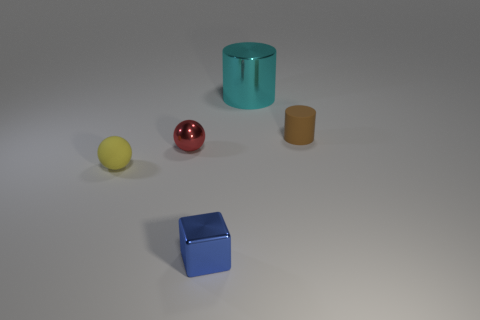Is the shape of the yellow object the same as the small red metallic thing that is on the left side of the big cyan cylinder?
Keep it short and to the point. Yes. Are there any tiny yellow objects that have the same shape as the red thing?
Provide a short and direct response. Yes. Are there the same number of tiny yellow objects that are behind the cyan cylinder and blue cubes?
Keep it short and to the point. No. How many other things are the same shape as the small yellow rubber object?
Your response must be concise. 1. There is a big shiny thing; what number of cylinders are right of it?
Keep it short and to the point. 1. What is the size of the object that is in front of the cyan shiny object and right of the blue thing?
Make the answer very short. Small. Are any big cylinders visible?
Keep it short and to the point. Yes. How many other objects are the same size as the yellow ball?
Provide a succinct answer. 3. The other object that is the same shape as the brown rubber thing is what size?
Ensure brevity in your answer.  Large. Does the cylinder on the right side of the big metal cylinder have the same material as the thing behind the tiny brown cylinder?
Ensure brevity in your answer.  No. 